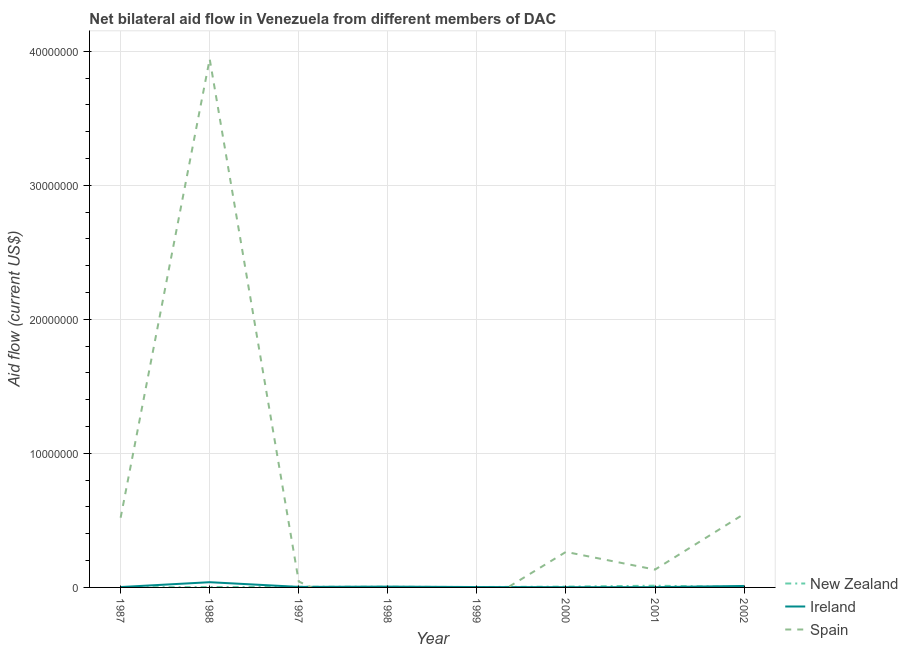How many different coloured lines are there?
Make the answer very short. 3. Does the line corresponding to amount of aid provided by ireland intersect with the line corresponding to amount of aid provided by spain?
Your answer should be very brief. Yes. What is the amount of aid provided by spain in 1988?
Give a very brief answer. 3.94e+07. Across all years, what is the maximum amount of aid provided by spain?
Keep it short and to the point. 3.94e+07. Across all years, what is the minimum amount of aid provided by ireland?
Make the answer very short. 2.00e+04. In which year was the amount of aid provided by ireland maximum?
Your answer should be very brief. 1988. What is the total amount of aid provided by new zealand in the graph?
Provide a short and direct response. 3.90e+05. What is the difference between the amount of aid provided by spain in 2000 and that in 2001?
Give a very brief answer. 1.32e+06. What is the difference between the amount of aid provided by ireland in 1988 and the amount of aid provided by spain in 2002?
Provide a succinct answer. -5.09e+06. What is the average amount of aid provided by spain per year?
Ensure brevity in your answer.  6.82e+06. In the year 2002, what is the difference between the amount of aid provided by spain and amount of aid provided by ireland?
Keep it short and to the point. 5.37e+06. In how many years, is the amount of aid provided by ireland greater than 18000000 US$?
Keep it short and to the point. 0. Is the difference between the amount of aid provided by ireland in 1997 and 2001 greater than the difference between the amount of aid provided by new zealand in 1997 and 2001?
Give a very brief answer. Yes. What is the difference between the highest and the second highest amount of aid provided by spain?
Give a very brief answer. 3.39e+07. What is the difference between the highest and the lowest amount of aid provided by spain?
Your response must be concise. 3.94e+07. Is the sum of the amount of aid provided by ireland in 1987 and 1998 greater than the maximum amount of aid provided by new zealand across all years?
Keep it short and to the point. No. Does the amount of aid provided by ireland monotonically increase over the years?
Keep it short and to the point. No. How many lines are there?
Your response must be concise. 3. How many years are there in the graph?
Give a very brief answer. 8. What is the difference between two consecutive major ticks on the Y-axis?
Your response must be concise. 1.00e+07. Are the values on the major ticks of Y-axis written in scientific E-notation?
Ensure brevity in your answer.  No. How many legend labels are there?
Your answer should be compact. 3. What is the title of the graph?
Offer a terse response. Net bilateral aid flow in Venezuela from different members of DAC. Does "Spain" appear as one of the legend labels in the graph?
Your response must be concise. Yes. What is the label or title of the Y-axis?
Your answer should be very brief. Aid flow (current US$). What is the Aid flow (current US$) in New Zealand in 1987?
Your answer should be very brief. 10000. What is the Aid flow (current US$) of Ireland in 1987?
Your answer should be compact. 3.00e+04. What is the Aid flow (current US$) of Spain in 1987?
Your answer should be compact. 5.20e+06. What is the Aid flow (current US$) of New Zealand in 1988?
Provide a succinct answer. 3.00e+04. What is the Aid flow (current US$) in Spain in 1988?
Give a very brief answer. 3.94e+07. What is the Aid flow (current US$) of Spain in 1997?
Offer a terse response. 4.40e+05. What is the Aid flow (current US$) of New Zealand in 1998?
Offer a terse response. 5.00e+04. What is the Aid flow (current US$) of Ireland in 1998?
Keep it short and to the point. 6.00e+04. What is the Aid flow (current US$) of Ireland in 1999?
Offer a very short reply. 3.00e+04. What is the Aid flow (current US$) in Spain in 1999?
Provide a succinct answer. 0. What is the Aid flow (current US$) in Ireland in 2000?
Your answer should be compact. 2.00e+04. What is the Aid flow (current US$) in Spain in 2000?
Offer a terse response. 2.65e+06. What is the Aid flow (current US$) of Spain in 2001?
Give a very brief answer. 1.33e+06. What is the Aid flow (current US$) of New Zealand in 2002?
Offer a terse response. 3.00e+04. What is the Aid flow (current US$) in Spain in 2002?
Provide a succinct answer. 5.48e+06. Across all years, what is the maximum Aid flow (current US$) in Spain?
Ensure brevity in your answer.  3.94e+07. Across all years, what is the minimum Aid flow (current US$) in Ireland?
Your response must be concise. 2.00e+04. Across all years, what is the minimum Aid flow (current US$) in Spain?
Your answer should be compact. 0. What is the total Aid flow (current US$) of New Zealand in the graph?
Your answer should be compact. 3.90e+05. What is the total Aid flow (current US$) of Spain in the graph?
Give a very brief answer. 5.45e+07. What is the difference between the Aid flow (current US$) of Ireland in 1987 and that in 1988?
Make the answer very short. -3.60e+05. What is the difference between the Aid flow (current US$) of Spain in 1987 and that in 1988?
Offer a very short reply. -3.42e+07. What is the difference between the Aid flow (current US$) of New Zealand in 1987 and that in 1997?
Your answer should be compact. -4.00e+04. What is the difference between the Aid flow (current US$) in Ireland in 1987 and that in 1997?
Your answer should be very brief. -10000. What is the difference between the Aid flow (current US$) of Spain in 1987 and that in 1997?
Give a very brief answer. 4.76e+06. What is the difference between the Aid flow (current US$) of Ireland in 1987 and that in 1998?
Offer a very short reply. -3.00e+04. What is the difference between the Aid flow (current US$) of New Zealand in 1987 and that in 1999?
Keep it short and to the point. -2.00e+04. What is the difference between the Aid flow (current US$) of Ireland in 1987 and that in 2000?
Provide a succinct answer. 10000. What is the difference between the Aid flow (current US$) of Spain in 1987 and that in 2000?
Give a very brief answer. 2.55e+06. What is the difference between the Aid flow (current US$) in Ireland in 1987 and that in 2001?
Give a very brief answer. 10000. What is the difference between the Aid flow (current US$) in Spain in 1987 and that in 2001?
Give a very brief answer. 3.87e+06. What is the difference between the Aid flow (current US$) of Ireland in 1987 and that in 2002?
Your answer should be very brief. -8.00e+04. What is the difference between the Aid flow (current US$) in Spain in 1987 and that in 2002?
Make the answer very short. -2.80e+05. What is the difference between the Aid flow (current US$) in New Zealand in 1988 and that in 1997?
Your response must be concise. -2.00e+04. What is the difference between the Aid flow (current US$) in Ireland in 1988 and that in 1997?
Give a very brief answer. 3.50e+05. What is the difference between the Aid flow (current US$) in Spain in 1988 and that in 1997?
Give a very brief answer. 3.90e+07. What is the difference between the Aid flow (current US$) in New Zealand in 1988 and that in 1998?
Your answer should be very brief. -2.00e+04. What is the difference between the Aid flow (current US$) in Ireland in 1988 and that in 1998?
Provide a short and direct response. 3.30e+05. What is the difference between the Aid flow (current US$) in New Zealand in 1988 and that in 2000?
Ensure brevity in your answer.  -3.00e+04. What is the difference between the Aid flow (current US$) in Ireland in 1988 and that in 2000?
Your answer should be compact. 3.70e+05. What is the difference between the Aid flow (current US$) in Spain in 1988 and that in 2000?
Ensure brevity in your answer.  3.68e+07. What is the difference between the Aid flow (current US$) in New Zealand in 1988 and that in 2001?
Your answer should be compact. -1.00e+05. What is the difference between the Aid flow (current US$) in Ireland in 1988 and that in 2001?
Make the answer very short. 3.70e+05. What is the difference between the Aid flow (current US$) in Spain in 1988 and that in 2001?
Your response must be concise. 3.81e+07. What is the difference between the Aid flow (current US$) of New Zealand in 1988 and that in 2002?
Offer a terse response. 0. What is the difference between the Aid flow (current US$) in Ireland in 1988 and that in 2002?
Offer a very short reply. 2.80e+05. What is the difference between the Aid flow (current US$) of Spain in 1988 and that in 2002?
Provide a short and direct response. 3.39e+07. What is the difference between the Aid flow (current US$) in New Zealand in 1997 and that in 1998?
Keep it short and to the point. 0. What is the difference between the Aid flow (current US$) in Ireland in 1997 and that in 1999?
Offer a terse response. 10000. What is the difference between the Aid flow (current US$) in Spain in 1997 and that in 2000?
Ensure brevity in your answer.  -2.21e+06. What is the difference between the Aid flow (current US$) in Ireland in 1997 and that in 2001?
Provide a short and direct response. 2.00e+04. What is the difference between the Aid flow (current US$) in Spain in 1997 and that in 2001?
Your answer should be compact. -8.90e+05. What is the difference between the Aid flow (current US$) in New Zealand in 1997 and that in 2002?
Provide a short and direct response. 2.00e+04. What is the difference between the Aid flow (current US$) in Spain in 1997 and that in 2002?
Your answer should be very brief. -5.04e+06. What is the difference between the Aid flow (current US$) in Ireland in 1998 and that in 1999?
Provide a short and direct response. 3.00e+04. What is the difference between the Aid flow (current US$) of Ireland in 1998 and that in 2000?
Your answer should be very brief. 4.00e+04. What is the difference between the Aid flow (current US$) of New Zealand in 1998 and that in 2002?
Provide a short and direct response. 2.00e+04. What is the difference between the Aid flow (current US$) in Ireland in 1998 and that in 2002?
Make the answer very short. -5.00e+04. What is the difference between the Aid flow (current US$) in New Zealand in 1999 and that in 2000?
Give a very brief answer. -3.00e+04. What is the difference between the Aid flow (current US$) of New Zealand in 1999 and that in 2002?
Give a very brief answer. 0. What is the difference between the Aid flow (current US$) of Ireland in 2000 and that in 2001?
Give a very brief answer. 0. What is the difference between the Aid flow (current US$) of Spain in 2000 and that in 2001?
Your answer should be compact. 1.32e+06. What is the difference between the Aid flow (current US$) of New Zealand in 2000 and that in 2002?
Make the answer very short. 3.00e+04. What is the difference between the Aid flow (current US$) in Ireland in 2000 and that in 2002?
Your answer should be very brief. -9.00e+04. What is the difference between the Aid flow (current US$) of Spain in 2000 and that in 2002?
Provide a short and direct response. -2.83e+06. What is the difference between the Aid flow (current US$) in New Zealand in 2001 and that in 2002?
Offer a very short reply. 1.00e+05. What is the difference between the Aid flow (current US$) of Spain in 2001 and that in 2002?
Give a very brief answer. -4.15e+06. What is the difference between the Aid flow (current US$) of New Zealand in 1987 and the Aid flow (current US$) of Ireland in 1988?
Your answer should be very brief. -3.80e+05. What is the difference between the Aid flow (current US$) in New Zealand in 1987 and the Aid flow (current US$) in Spain in 1988?
Your answer should be compact. -3.94e+07. What is the difference between the Aid flow (current US$) of Ireland in 1987 and the Aid flow (current US$) of Spain in 1988?
Provide a short and direct response. -3.94e+07. What is the difference between the Aid flow (current US$) in New Zealand in 1987 and the Aid flow (current US$) in Spain in 1997?
Give a very brief answer. -4.30e+05. What is the difference between the Aid flow (current US$) of Ireland in 1987 and the Aid flow (current US$) of Spain in 1997?
Provide a succinct answer. -4.10e+05. What is the difference between the Aid flow (current US$) of New Zealand in 1987 and the Aid flow (current US$) of Ireland in 1999?
Give a very brief answer. -2.00e+04. What is the difference between the Aid flow (current US$) in New Zealand in 1987 and the Aid flow (current US$) in Ireland in 2000?
Keep it short and to the point. -10000. What is the difference between the Aid flow (current US$) of New Zealand in 1987 and the Aid flow (current US$) of Spain in 2000?
Offer a very short reply. -2.64e+06. What is the difference between the Aid flow (current US$) of Ireland in 1987 and the Aid flow (current US$) of Spain in 2000?
Give a very brief answer. -2.62e+06. What is the difference between the Aid flow (current US$) of New Zealand in 1987 and the Aid flow (current US$) of Spain in 2001?
Give a very brief answer. -1.32e+06. What is the difference between the Aid flow (current US$) in Ireland in 1987 and the Aid flow (current US$) in Spain in 2001?
Your response must be concise. -1.30e+06. What is the difference between the Aid flow (current US$) of New Zealand in 1987 and the Aid flow (current US$) of Ireland in 2002?
Ensure brevity in your answer.  -1.00e+05. What is the difference between the Aid flow (current US$) in New Zealand in 1987 and the Aid flow (current US$) in Spain in 2002?
Keep it short and to the point. -5.47e+06. What is the difference between the Aid flow (current US$) in Ireland in 1987 and the Aid flow (current US$) in Spain in 2002?
Provide a succinct answer. -5.45e+06. What is the difference between the Aid flow (current US$) in New Zealand in 1988 and the Aid flow (current US$) in Spain in 1997?
Ensure brevity in your answer.  -4.10e+05. What is the difference between the Aid flow (current US$) of New Zealand in 1988 and the Aid flow (current US$) of Ireland in 1999?
Ensure brevity in your answer.  0. What is the difference between the Aid flow (current US$) in New Zealand in 1988 and the Aid flow (current US$) in Ireland in 2000?
Provide a short and direct response. 10000. What is the difference between the Aid flow (current US$) in New Zealand in 1988 and the Aid flow (current US$) in Spain in 2000?
Provide a succinct answer. -2.62e+06. What is the difference between the Aid flow (current US$) in Ireland in 1988 and the Aid flow (current US$) in Spain in 2000?
Offer a terse response. -2.26e+06. What is the difference between the Aid flow (current US$) in New Zealand in 1988 and the Aid flow (current US$) in Ireland in 2001?
Your response must be concise. 10000. What is the difference between the Aid flow (current US$) in New Zealand in 1988 and the Aid flow (current US$) in Spain in 2001?
Provide a short and direct response. -1.30e+06. What is the difference between the Aid flow (current US$) of Ireland in 1988 and the Aid flow (current US$) of Spain in 2001?
Your answer should be very brief. -9.40e+05. What is the difference between the Aid flow (current US$) of New Zealand in 1988 and the Aid flow (current US$) of Spain in 2002?
Your answer should be compact. -5.45e+06. What is the difference between the Aid flow (current US$) of Ireland in 1988 and the Aid flow (current US$) of Spain in 2002?
Offer a very short reply. -5.09e+06. What is the difference between the Aid flow (current US$) of New Zealand in 1997 and the Aid flow (current US$) of Ireland in 1998?
Your answer should be very brief. -10000. What is the difference between the Aid flow (current US$) of New Zealand in 1997 and the Aid flow (current US$) of Ireland in 1999?
Make the answer very short. 2.00e+04. What is the difference between the Aid flow (current US$) of New Zealand in 1997 and the Aid flow (current US$) of Spain in 2000?
Provide a short and direct response. -2.60e+06. What is the difference between the Aid flow (current US$) of Ireland in 1997 and the Aid flow (current US$) of Spain in 2000?
Your answer should be compact. -2.61e+06. What is the difference between the Aid flow (current US$) in New Zealand in 1997 and the Aid flow (current US$) in Ireland in 2001?
Provide a succinct answer. 3.00e+04. What is the difference between the Aid flow (current US$) in New Zealand in 1997 and the Aid flow (current US$) in Spain in 2001?
Keep it short and to the point. -1.28e+06. What is the difference between the Aid flow (current US$) of Ireland in 1997 and the Aid flow (current US$) of Spain in 2001?
Your answer should be compact. -1.29e+06. What is the difference between the Aid flow (current US$) of New Zealand in 1997 and the Aid flow (current US$) of Ireland in 2002?
Offer a terse response. -6.00e+04. What is the difference between the Aid flow (current US$) in New Zealand in 1997 and the Aid flow (current US$) in Spain in 2002?
Provide a short and direct response. -5.43e+06. What is the difference between the Aid flow (current US$) in Ireland in 1997 and the Aid flow (current US$) in Spain in 2002?
Provide a succinct answer. -5.44e+06. What is the difference between the Aid flow (current US$) in New Zealand in 1998 and the Aid flow (current US$) in Ireland in 2000?
Make the answer very short. 3.00e+04. What is the difference between the Aid flow (current US$) in New Zealand in 1998 and the Aid flow (current US$) in Spain in 2000?
Give a very brief answer. -2.60e+06. What is the difference between the Aid flow (current US$) in Ireland in 1998 and the Aid flow (current US$) in Spain in 2000?
Keep it short and to the point. -2.59e+06. What is the difference between the Aid flow (current US$) of New Zealand in 1998 and the Aid flow (current US$) of Spain in 2001?
Your answer should be compact. -1.28e+06. What is the difference between the Aid flow (current US$) in Ireland in 1998 and the Aid flow (current US$) in Spain in 2001?
Provide a short and direct response. -1.27e+06. What is the difference between the Aid flow (current US$) of New Zealand in 1998 and the Aid flow (current US$) of Ireland in 2002?
Provide a short and direct response. -6.00e+04. What is the difference between the Aid flow (current US$) of New Zealand in 1998 and the Aid flow (current US$) of Spain in 2002?
Offer a terse response. -5.43e+06. What is the difference between the Aid flow (current US$) in Ireland in 1998 and the Aid flow (current US$) in Spain in 2002?
Your response must be concise. -5.42e+06. What is the difference between the Aid flow (current US$) of New Zealand in 1999 and the Aid flow (current US$) of Ireland in 2000?
Make the answer very short. 10000. What is the difference between the Aid flow (current US$) of New Zealand in 1999 and the Aid flow (current US$) of Spain in 2000?
Ensure brevity in your answer.  -2.62e+06. What is the difference between the Aid flow (current US$) in Ireland in 1999 and the Aid flow (current US$) in Spain in 2000?
Provide a succinct answer. -2.62e+06. What is the difference between the Aid flow (current US$) in New Zealand in 1999 and the Aid flow (current US$) in Spain in 2001?
Keep it short and to the point. -1.30e+06. What is the difference between the Aid flow (current US$) in Ireland in 1999 and the Aid flow (current US$) in Spain in 2001?
Your answer should be compact. -1.30e+06. What is the difference between the Aid flow (current US$) of New Zealand in 1999 and the Aid flow (current US$) of Ireland in 2002?
Provide a succinct answer. -8.00e+04. What is the difference between the Aid flow (current US$) in New Zealand in 1999 and the Aid flow (current US$) in Spain in 2002?
Offer a very short reply. -5.45e+06. What is the difference between the Aid flow (current US$) of Ireland in 1999 and the Aid flow (current US$) of Spain in 2002?
Make the answer very short. -5.45e+06. What is the difference between the Aid flow (current US$) in New Zealand in 2000 and the Aid flow (current US$) in Ireland in 2001?
Provide a succinct answer. 4.00e+04. What is the difference between the Aid flow (current US$) of New Zealand in 2000 and the Aid flow (current US$) of Spain in 2001?
Offer a terse response. -1.27e+06. What is the difference between the Aid flow (current US$) in Ireland in 2000 and the Aid flow (current US$) in Spain in 2001?
Offer a very short reply. -1.31e+06. What is the difference between the Aid flow (current US$) of New Zealand in 2000 and the Aid flow (current US$) of Ireland in 2002?
Provide a succinct answer. -5.00e+04. What is the difference between the Aid flow (current US$) of New Zealand in 2000 and the Aid flow (current US$) of Spain in 2002?
Offer a terse response. -5.42e+06. What is the difference between the Aid flow (current US$) in Ireland in 2000 and the Aid flow (current US$) in Spain in 2002?
Provide a short and direct response. -5.46e+06. What is the difference between the Aid flow (current US$) of New Zealand in 2001 and the Aid flow (current US$) of Spain in 2002?
Provide a short and direct response. -5.35e+06. What is the difference between the Aid flow (current US$) in Ireland in 2001 and the Aid flow (current US$) in Spain in 2002?
Provide a succinct answer. -5.46e+06. What is the average Aid flow (current US$) of New Zealand per year?
Your answer should be very brief. 4.88e+04. What is the average Aid flow (current US$) of Ireland per year?
Provide a short and direct response. 8.75e+04. What is the average Aid flow (current US$) in Spain per year?
Provide a succinct answer. 6.82e+06. In the year 1987, what is the difference between the Aid flow (current US$) of New Zealand and Aid flow (current US$) of Spain?
Ensure brevity in your answer.  -5.19e+06. In the year 1987, what is the difference between the Aid flow (current US$) in Ireland and Aid flow (current US$) in Spain?
Provide a succinct answer. -5.17e+06. In the year 1988, what is the difference between the Aid flow (current US$) in New Zealand and Aid flow (current US$) in Ireland?
Make the answer very short. -3.60e+05. In the year 1988, what is the difference between the Aid flow (current US$) of New Zealand and Aid flow (current US$) of Spain?
Keep it short and to the point. -3.94e+07. In the year 1988, what is the difference between the Aid flow (current US$) in Ireland and Aid flow (current US$) in Spain?
Your answer should be compact. -3.90e+07. In the year 1997, what is the difference between the Aid flow (current US$) of New Zealand and Aid flow (current US$) of Spain?
Make the answer very short. -3.90e+05. In the year 1997, what is the difference between the Aid flow (current US$) in Ireland and Aid flow (current US$) in Spain?
Provide a succinct answer. -4.00e+05. In the year 1999, what is the difference between the Aid flow (current US$) in New Zealand and Aid flow (current US$) in Ireland?
Your answer should be compact. 0. In the year 2000, what is the difference between the Aid flow (current US$) in New Zealand and Aid flow (current US$) in Spain?
Your answer should be very brief. -2.59e+06. In the year 2000, what is the difference between the Aid flow (current US$) in Ireland and Aid flow (current US$) in Spain?
Offer a terse response. -2.63e+06. In the year 2001, what is the difference between the Aid flow (current US$) in New Zealand and Aid flow (current US$) in Spain?
Offer a very short reply. -1.20e+06. In the year 2001, what is the difference between the Aid flow (current US$) of Ireland and Aid flow (current US$) of Spain?
Offer a very short reply. -1.31e+06. In the year 2002, what is the difference between the Aid flow (current US$) in New Zealand and Aid flow (current US$) in Ireland?
Make the answer very short. -8.00e+04. In the year 2002, what is the difference between the Aid flow (current US$) of New Zealand and Aid flow (current US$) of Spain?
Your answer should be very brief. -5.45e+06. In the year 2002, what is the difference between the Aid flow (current US$) in Ireland and Aid flow (current US$) in Spain?
Give a very brief answer. -5.37e+06. What is the ratio of the Aid flow (current US$) in New Zealand in 1987 to that in 1988?
Ensure brevity in your answer.  0.33. What is the ratio of the Aid flow (current US$) in Ireland in 1987 to that in 1988?
Offer a very short reply. 0.08. What is the ratio of the Aid flow (current US$) of Spain in 1987 to that in 1988?
Provide a short and direct response. 0.13. What is the ratio of the Aid flow (current US$) of Ireland in 1987 to that in 1997?
Provide a short and direct response. 0.75. What is the ratio of the Aid flow (current US$) of Spain in 1987 to that in 1997?
Offer a very short reply. 11.82. What is the ratio of the Aid flow (current US$) in New Zealand in 1987 to that in 1998?
Offer a terse response. 0.2. What is the ratio of the Aid flow (current US$) of Ireland in 1987 to that in 1998?
Offer a very short reply. 0.5. What is the ratio of the Aid flow (current US$) of Ireland in 1987 to that in 1999?
Your answer should be very brief. 1. What is the ratio of the Aid flow (current US$) of New Zealand in 1987 to that in 2000?
Your response must be concise. 0.17. What is the ratio of the Aid flow (current US$) in Ireland in 1987 to that in 2000?
Ensure brevity in your answer.  1.5. What is the ratio of the Aid flow (current US$) of Spain in 1987 to that in 2000?
Provide a short and direct response. 1.96. What is the ratio of the Aid flow (current US$) in New Zealand in 1987 to that in 2001?
Provide a succinct answer. 0.08. What is the ratio of the Aid flow (current US$) of Spain in 1987 to that in 2001?
Keep it short and to the point. 3.91. What is the ratio of the Aid flow (current US$) in Ireland in 1987 to that in 2002?
Your answer should be very brief. 0.27. What is the ratio of the Aid flow (current US$) in Spain in 1987 to that in 2002?
Your answer should be compact. 0.95. What is the ratio of the Aid flow (current US$) of Ireland in 1988 to that in 1997?
Offer a terse response. 9.75. What is the ratio of the Aid flow (current US$) of Spain in 1988 to that in 1997?
Make the answer very short. 89.59. What is the ratio of the Aid flow (current US$) of Ireland in 1988 to that in 1998?
Your response must be concise. 6.5. What is the ratio of the Aid flow (current US$) in New Zealand in 1988 to that in 1999?
Keep it short and to the point. 1. What is the ratio of the Aid flow (current US$) in Ireland in 1988 to that in 2000?
Offer a terse response. 19.5. What is the ratio of the Aid flow (current US$) in Spain in 1988 to that in 2000?
Make the answer very short. 14.88. What is the ratio of the Aid flow (current US$) of New Zealand in 1988 to that in 2001?
Offer a terse response. 0.23. What is the ratio of the Aid flow (current US$) in Spain in 1988 to that in 2001?
Make the answer very short. 29.64. What is the ratio of the Aid flow (current US$) of New Zealand in 1988 to that in 2002?
Ensure brevity in your answer.  1. What is the ratio of the Aid flow (current US$) of Ireland in 1988 to that in 2002?
Keep it short and to the point. 3.55. What is the ratio of the Aid flow (current US$) in Spain in 1988 to that in 2002?
Your response must be concise. 7.19. What is the ratio of the Aid flow (current US$) of New Zealand in 1997 to that in 1998?
Keep it short and to the point. 1. What is the ratio of the Aid flow (current US$) in Ireland in 1997 to that in 1998?
Your response must be concise. 0.67. What is the ratio of the Aid flow (current US$) in New Zealand in 1997 to that in 2000?
Your answer should be compact. 0.83. What is the ratio of the Aid flow (current US$) of Spain in 1997 to that in 2000?
Provide a succinct answer. 0.17. What is the ratio of the Aid flow (current US$) in New Zealand in 1997 to that in 2001?
Provide a succinct answer. 0.38. What is the ratio of the Aid flow (current US$) in Spain in 1997 to that in 2001?
Offer a very short reply. 0.33. What is the ratio of the Aid flow (current US$) of New Zealand in 1997 to that in 2002?
Your response must be concise. 1.67. What is the ratio of the Aid flow (current US$) of Ireland in 1997 to that in 2002?
Offer a terse response. 0.36. What is the ratio of the Aid flow (current US$) of Spain in 1997 to that in 2002?
Keep it short and to the point. 0.08. What is the ratio of the Aid flow (current US$) in New Zealand in 1998 to that in 1999?
Make the answer very short. 1.67. What is the ratio of the Aid flow (current US$) in Ireland in 1998 to that in 1999?
Make the answer very short. 2. What is the ratio of the Aid flow (current US$) in Ireland in 1998 to that in 2000?
Ensure brevity in your answer.  3. What is the ratio of the Aid flow (current US$) in New Zealand in 1998 to that in 2001?
Offer a very short reply. 0.38. What is the ratio of the Aid flow (current US$) in Ireland in 1998 to that in 2002?
Your answer should be compact. 0.55. What is the ratio of the Aid flow (current US$) of New Zealand in 1999 to that in 2000?
Offer a very short reply. 0.5. What is the ratio of the Aid flow (current US$) in New Zealand in 1999 to that in 2001?
Ensure brevity in your answer.  0.23. What is the ratio of the Aid flow (current US$) of Ireland in 1999 to that in 2002?
Offer a very short reply. 0.27. What is the ratio of the Aid flow (current US$) of New Zealand in 2000 to that in 2001?
Offer a very short reply. 0.46. What is the ratio of the Aid flow (current US$) of Spain in 2000 to that in 2001?
Provide a short and direct response. 1.99. What is the ratio of the Aid flow (current US$) of Ireland in 2000 to that in 2002?
Give a very brief answer. 0.18. What is the ratio of the Aid flow (current US$) in Spain in 2000 to that in 2002?
Make the answer very short. 0.48. What is the ratio of the Aid flow (current US$) of New Zealand in 2001 to that in 2002?
Provide a succinct answer. 4.33. What is the ratio of the Aid flow (current US$) in Ireland in 2001 to that in 2002?
Make the answer very short. 0.18. What is the ratio of the Aid flow (current US$) in Spain in 2001 to that in 2002?
Give a very brief answer. 0.24. What is the difference between the highest and the second highest Aid flow (current US$) in New Zealand?
Your answer should be very brief. 7.00e+04. What is the difference between the highest and the second highest Aid flow (current US$) of Spain?
Make the answer very short. 3.39e+07. What is the difference between the highest and the lowest Aid flow (current US$) in Ireland?
Offer a terse response. 3.70e+05. What is the difference between the highest and the lowest Aid flow (current US$) in Spain?
Your answer should be compact. 3.94e+07. 